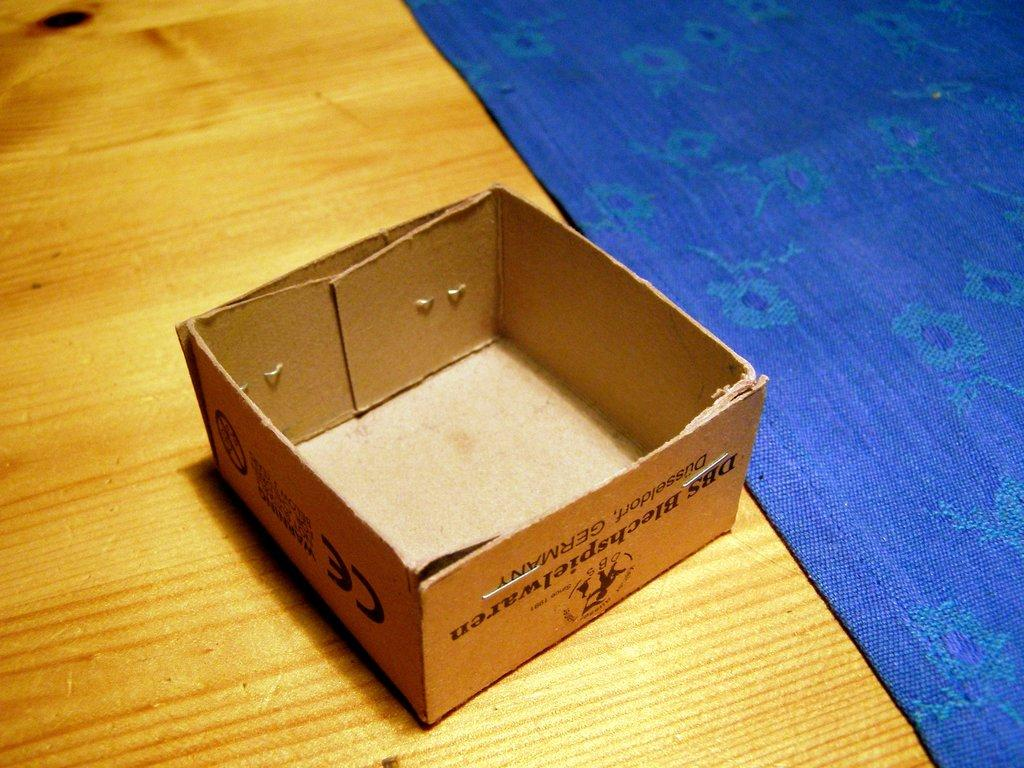<image>
Provide a brief description of the given image. A small box from DBS Blechshpielware, Dusseldorf Germany is empty and upside down on a wooden surface. 